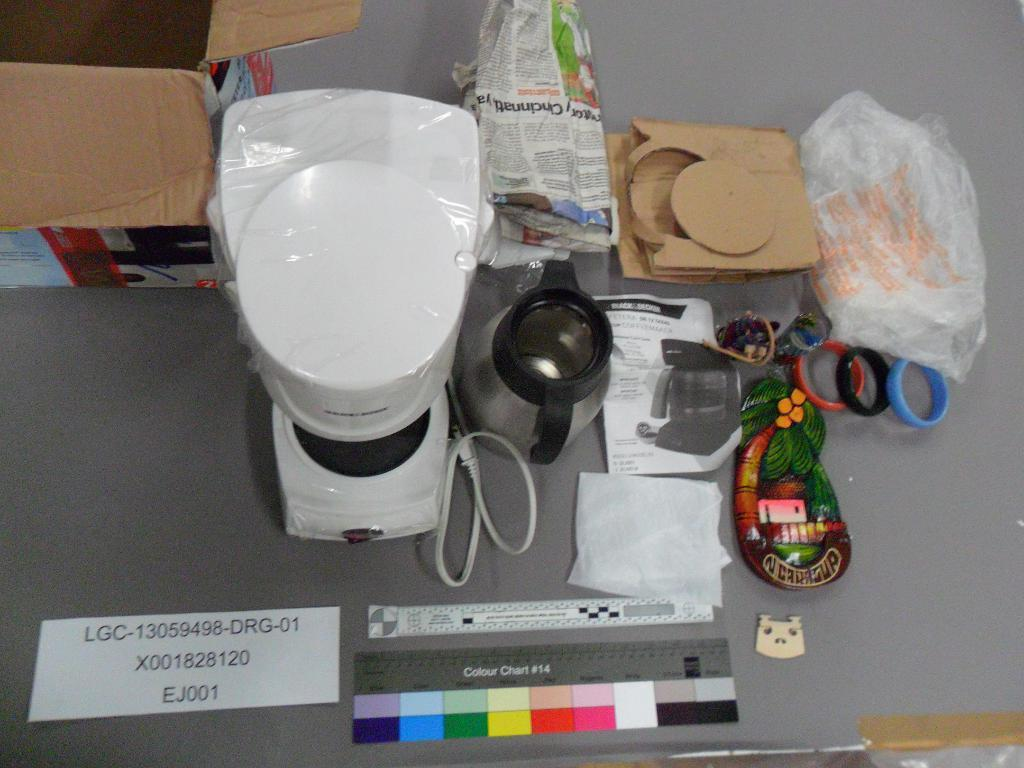<image>
Offer a succinct explanation of the picture presented. A gray table is littered with various random items, including coffee making materials and a visual aid called Colour Chart #14. 